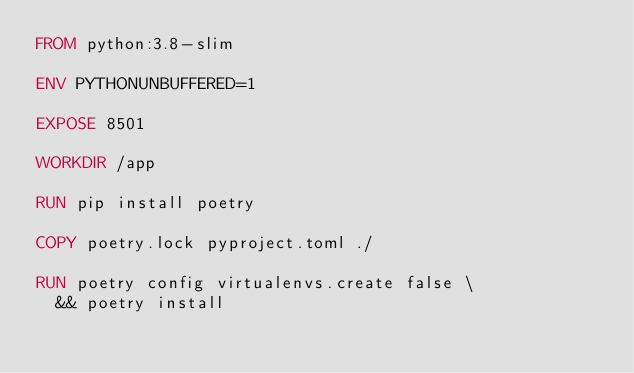Convert code to text. <code><loc_0><loc_0><loc_500><loc_500><_Dockerfile_>FROM python:3.8-slim

ENV PYTHONUNBUFFERED=1

EXPOSE 8501

WORKDIR /app

RUN pip install poetry

COPY poetry.lock pyproject.toml ./

RUN poetry config virtualenvs.create false \
  && poetry install
</code> 